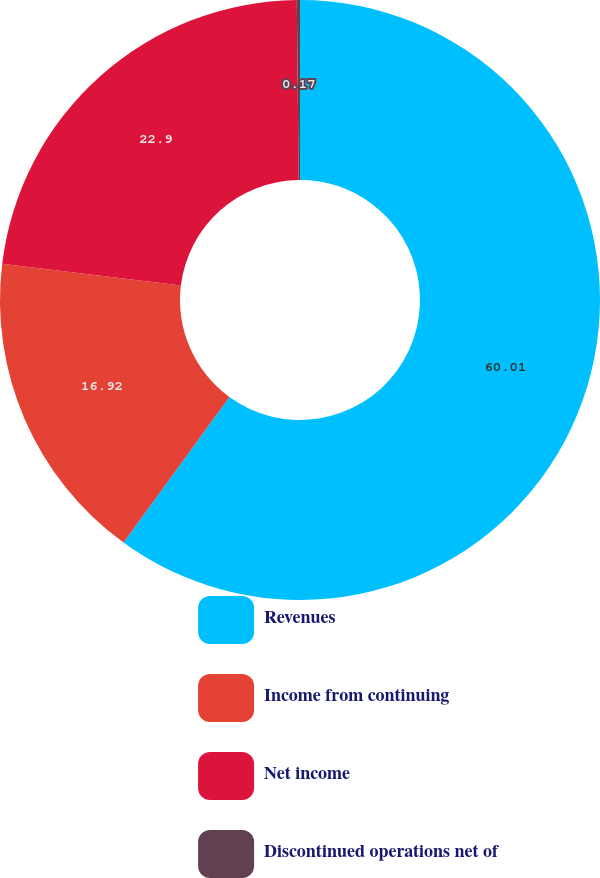<chart> <loc_0><loc_0><loc_500><loc_500><pie_chart><fcel>Revenues<fcel>Income from continuing<fcel>Net income<fcel>Discontinued operations net of<nl><fcel>60.01%<fcel>16.92%<fcel>22.9%<fcel>0.17%<nl></chart> 